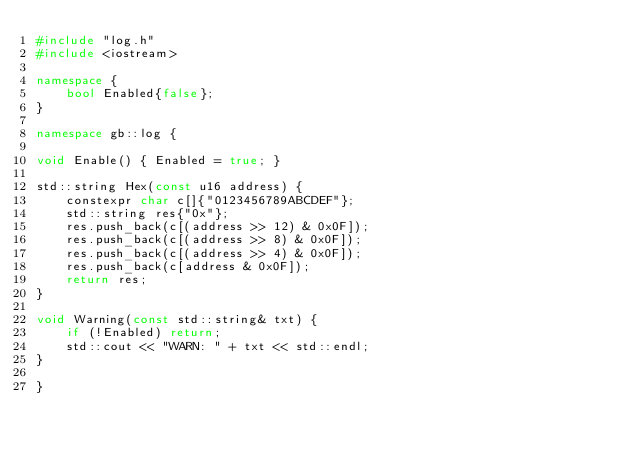<code> <loc_0><loc_0><loc_500><loc_500><_C++_>#include "log.h"
#include <iostream>

namespace {
    bool Enabled{false};
}

namespace gb::log {

void Enable() { Enabled = true; }

std::string Hex(const u16 address) {
    constexpr char c[]{"0123456789ABCDEF"};
    std::string res{"0x"};
    res.push_back(c[(address >> 12) & 0x0F]);
    res.push_back(c[(address >> 8) & 0x0F]);
    res.push_back(c[(address >> 4) & 0x0F]);
    res.push_back(c[address & 0x0F]);
    return res;
}

void Warning(const std::string& txt) {
    if (!Enabled) return;
    std::cout << "WARN: " + txt << std::endl;
}

}
</code> 